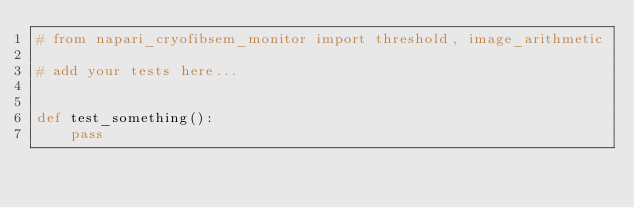Convert code to text. <code><loc_0><loc_0><loc_500><loc_500><_Python_># from napari_cryofibsem_monitor import threshold, image_arithmetic

# add your tests here...


def test_something():
    pass
</code> 